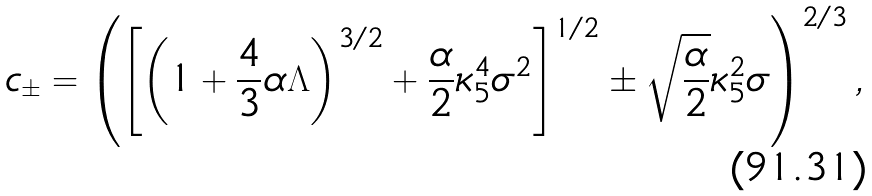<formula> <loc_0><loc_0><loc_500><loc_500>c _ { \pm } = \left ( \left [ \left ( 1 + \frac { 4 } { 3 } \alpha \Lambda \right ) ^ { 3 / 2 } + \frac { \alpha } { 2 } \kappa _ { 5 } ^ { 4 } \sigma ^ { 2 } \right ] ^ { 1 / 2 } \pm \sqrt { \frac { \alpha } { 2 } } \kappa _ { 5 } ^ { 2 } \sigma \right ) ^ { 2 / 3 } ,</formula> 